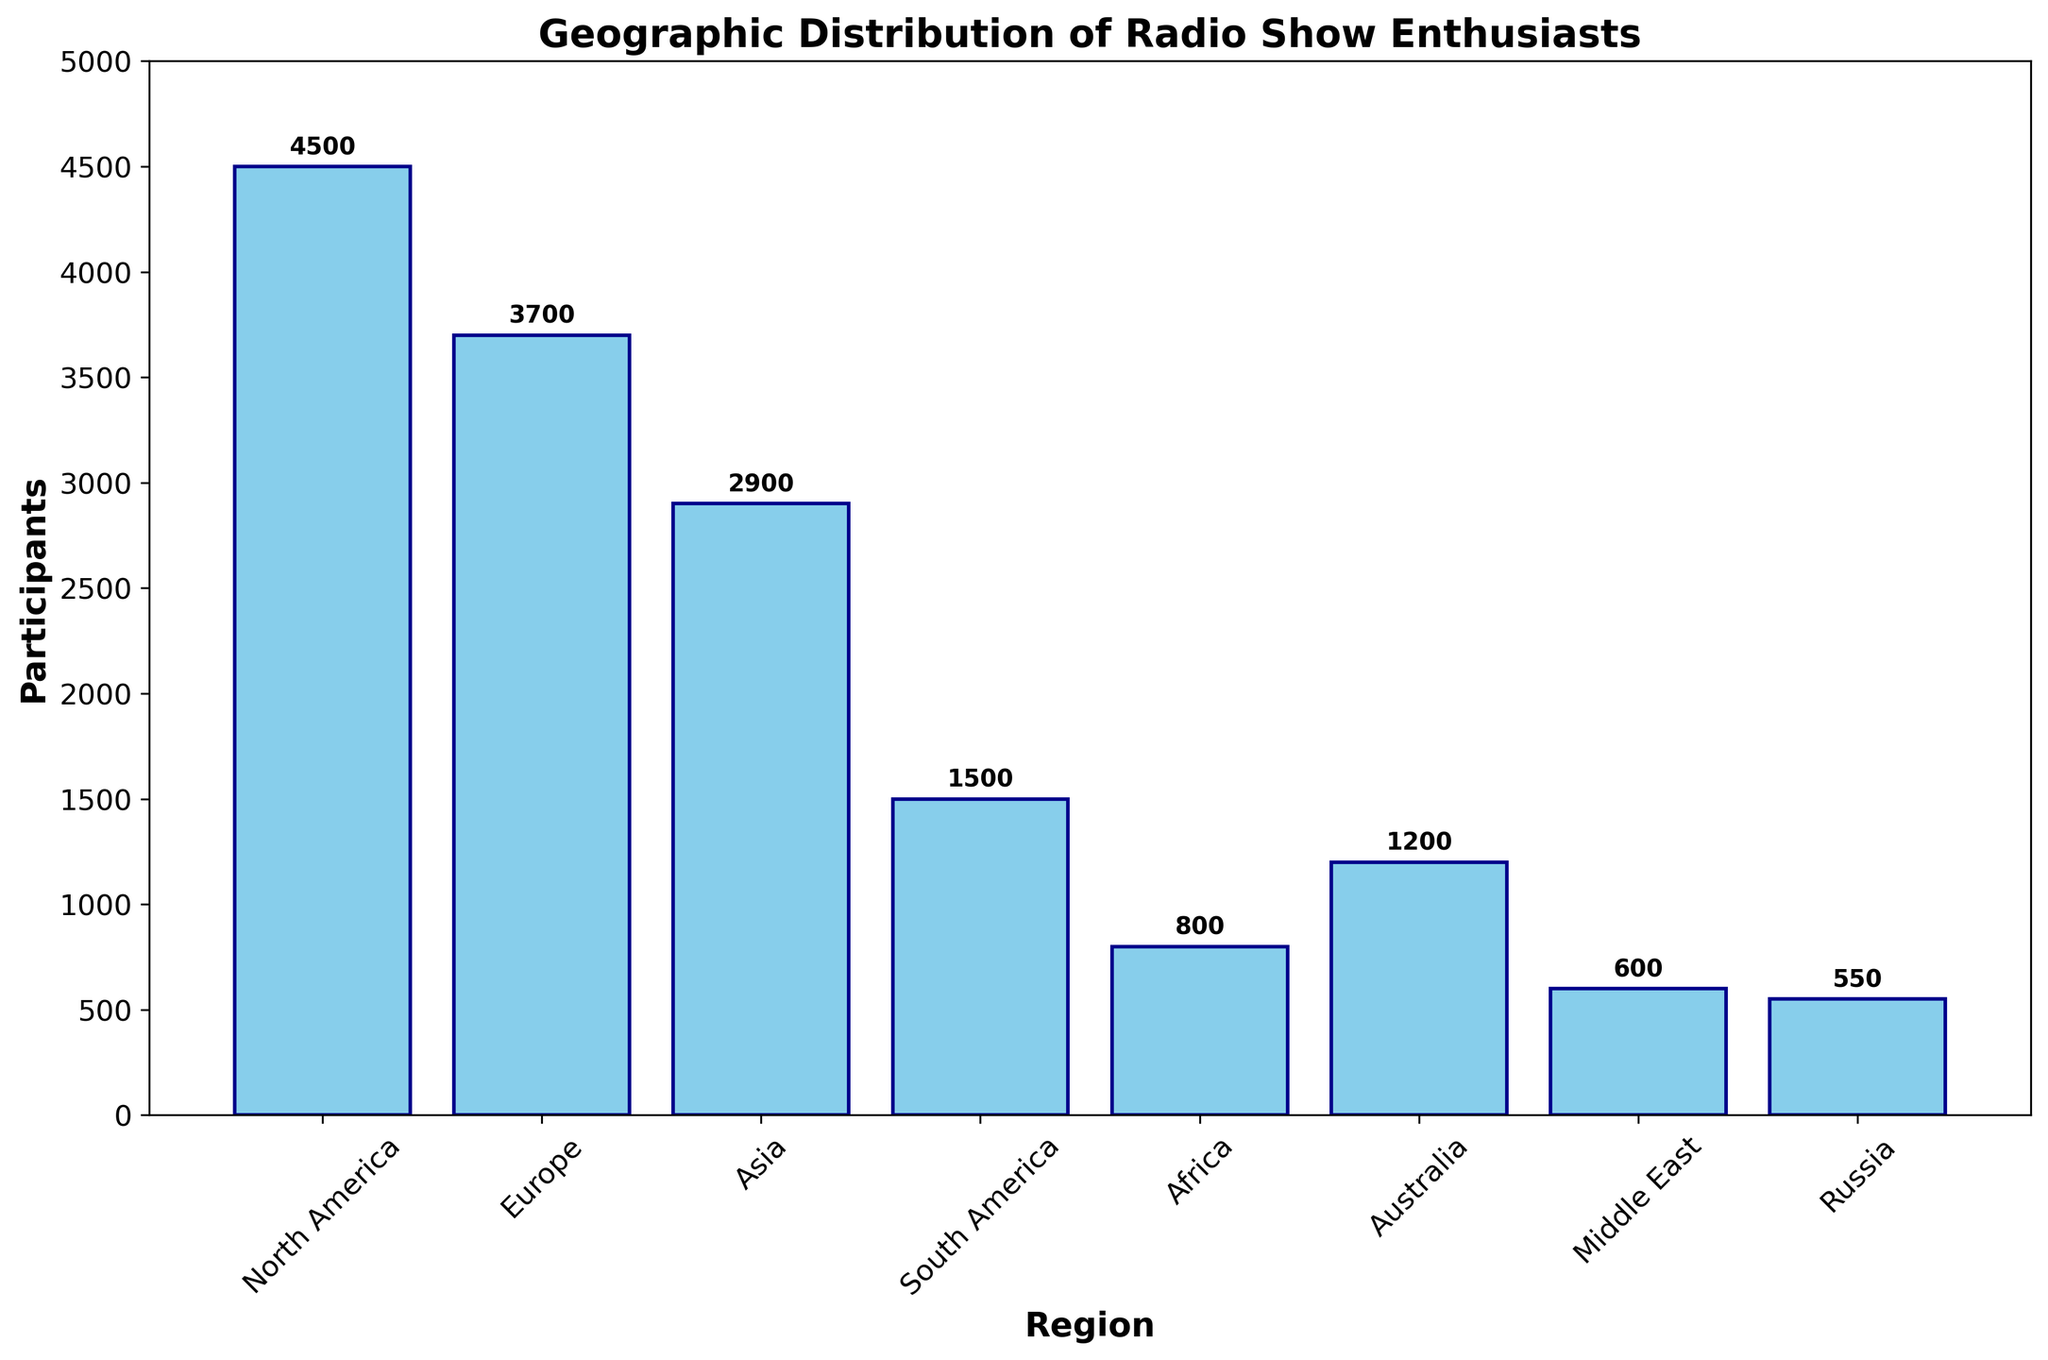Which region has the highest number of radio show enthusiasts participating in online communities? The region with the highest bar represents the highest number of radio show enthusiasts. The bar for North America is the tallest, indicating 4500 participants.
Answer: North America What is the total number of participants in Europe and Asia combined? To find this total, sum the number of participants in Europe and Asia. Europe has 3700 participants, and Asia has 2900 participants. Therefore, 3700 + 2900 = 6600.
Answer: 6600 How many more participants are there in North America compared to South America? To find the difference, subtract the number of participants in South America from North America. North America has 4500 participants, and South America has 1500 participants. Therefore, 4500 - 1500 = 3000.
Answer: 3000 Which regions have fewer than 1000 participants? Fewer than 1000 participants points to bars below the 1000 mark. Both Africa (800) and the Middle East (600) meet this criterion.
Answer: Africa, Middle East What is the average number of participants across all regions? To calculate the average, sum the number of participants from all regions and divide by the number of regions. The total is 4500 + 3700 + 2900 + 1500 + 800 + 1200 + 600 + 550 = 15750. There are 8 regions. So, 15750 / 8 = 1968.75.
Answer: 1968.75 What is the sum of participants in regions with more than 2000 participants? Sum the participants in regions where the participant number exceeds 2000. North America (4500), Europe (3700), and Asia (2900) fit this criterion. Therefore, 4500 + 3700 + 2900 = 11100.
Answer: 11100 Which region has the smallest number of participants, and how many are there? The region with the shortest bar has the fewest participants. The bar for Russia is the shortest, with 550 participants.
Answer: Russia, 550 How many participants are there in regions that start with the letter 'A'? Sum the participants in Africa (800) and Australia (1200). Therefore, 800 + 1200 = 2000.
Answer: 2000 